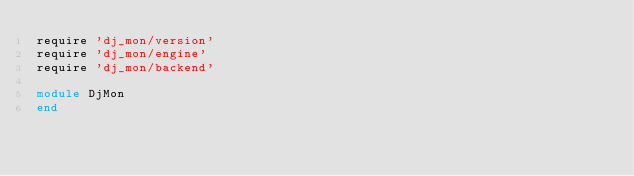<code> <loc_0><loc_0><loc_500><loc_500><_Ruby_>require 'dj_mon/version'
require 'dj_mon/engine'
require 'dj_mon/backend'

module DjMon
end</code> 